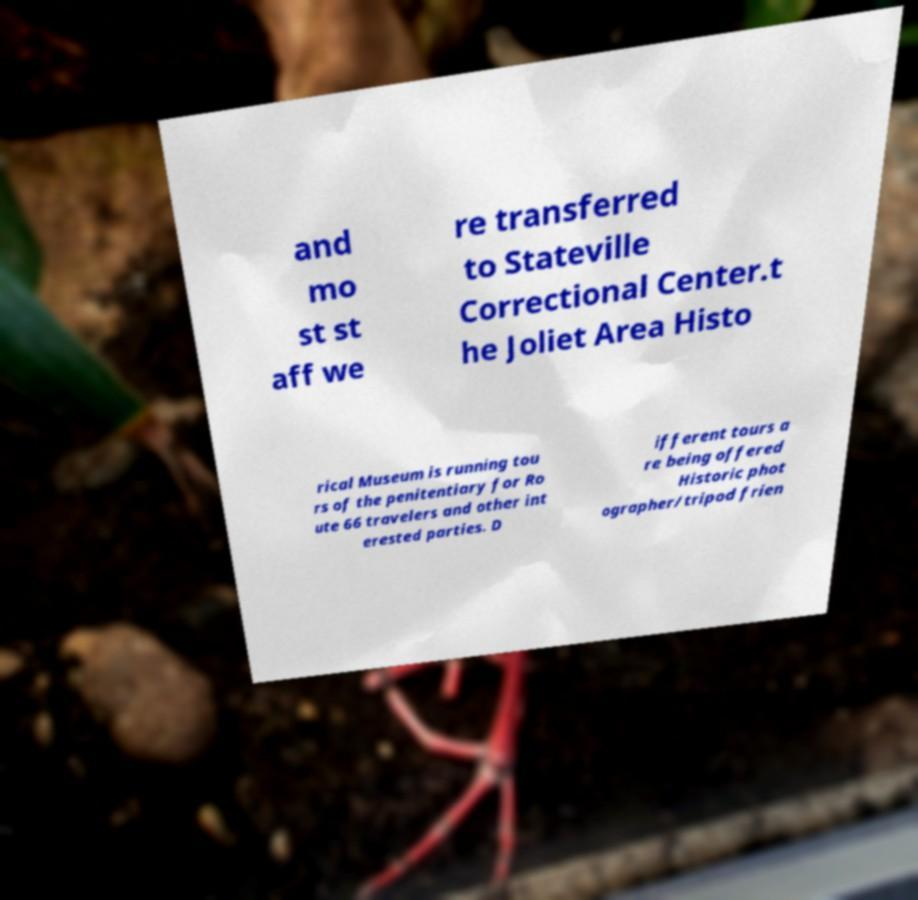Could you assist in decoding the text presented in this image and type it out clearly? and mo st st aff we re transferred to Stateville Correctional Center.t he Joliet Area Histo rical Museum is running tou rs of the penitentiary for Ro ute 66 travelers and other int erested parties. D ifferent tours a re being offered Historic phot ographer/tripod frien 